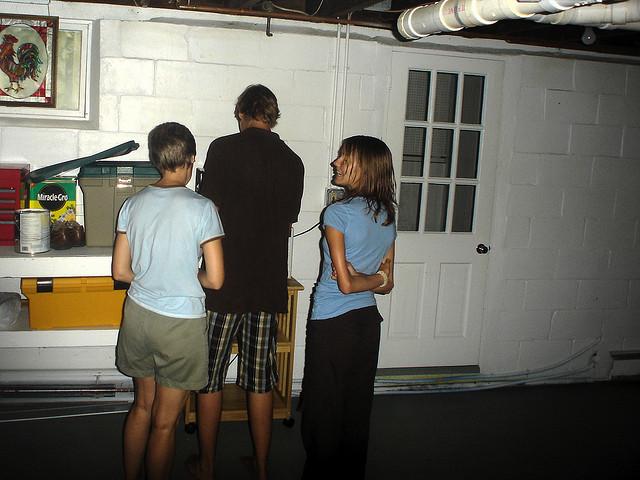What is the wall made of?
Short answer required. Cement blocks. Does the room need painting?
Write a very short answer. No. How many people are there?
Keep it brief. 3. 